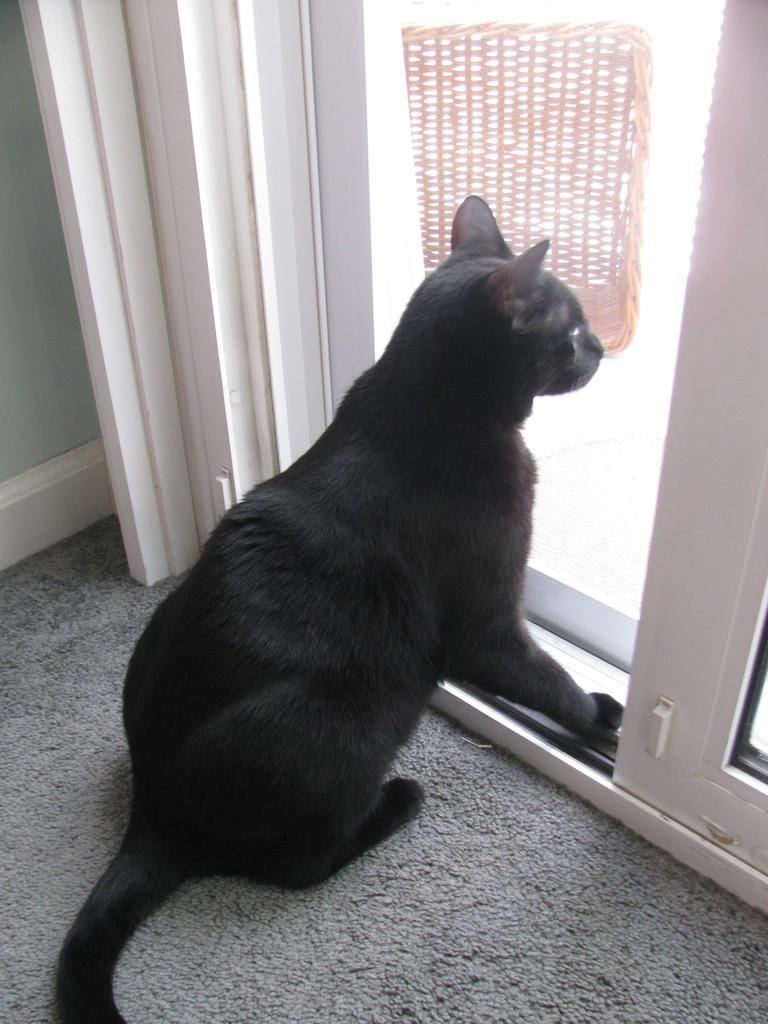What type of animal is in the image? There is a cat in the image. Where is the cat located in relation to other objects in the image? The cat is near a door. What other object can be seen in the image? There is a wooden basket in the image. What type of flooring is visible in the image? There is a carpet on the floor in the image. What property does the cat own in the image? The cat does not own any property in the image; it is an animal and cannot own property. 